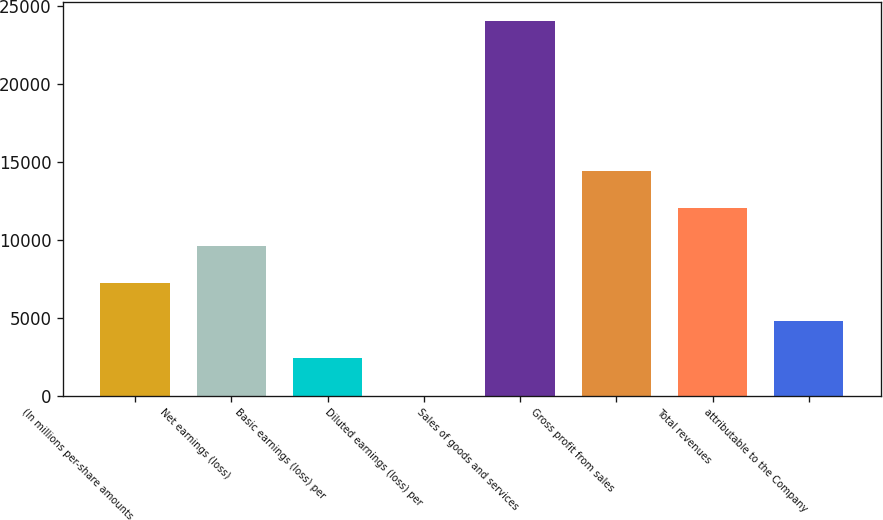Convert chart to OTSL. <chart><loc_0><loc_0><loc_500><loc_500><bar_chart><fcel>(In millions per-share amounts<fcel>Net earnings (loss)<fcel>Basic earnings (loss) per<fcel>Diluted earnings (loss) per<fcel>Sales of goods and services<fcel>Gross profit from sales<fcel>Total revenues<fcel>attributable to the Company<nl><fcel>7203.41<fcel>9604.5<fcel>2401.23<fcel>0.14<fcel>24011<fcel>14406.7<fcel>12005.6<fcel>4802.32<nl></chart> 